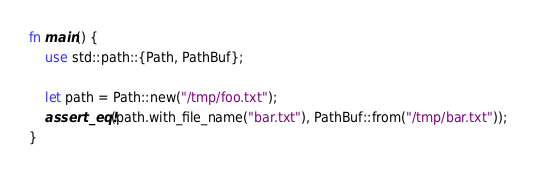<code> <loc_0><loc_0><loc_500><loc_500><_Rust_>fn main() {
    use std::path::{Path, PathBuf};
    
    let path = Path::new("/tmp/foo.txt");
    assert_eq!(path.with_file_name("bar.txt"), PathBuf::from("/tmp/bar.txt"));
}
</code> 